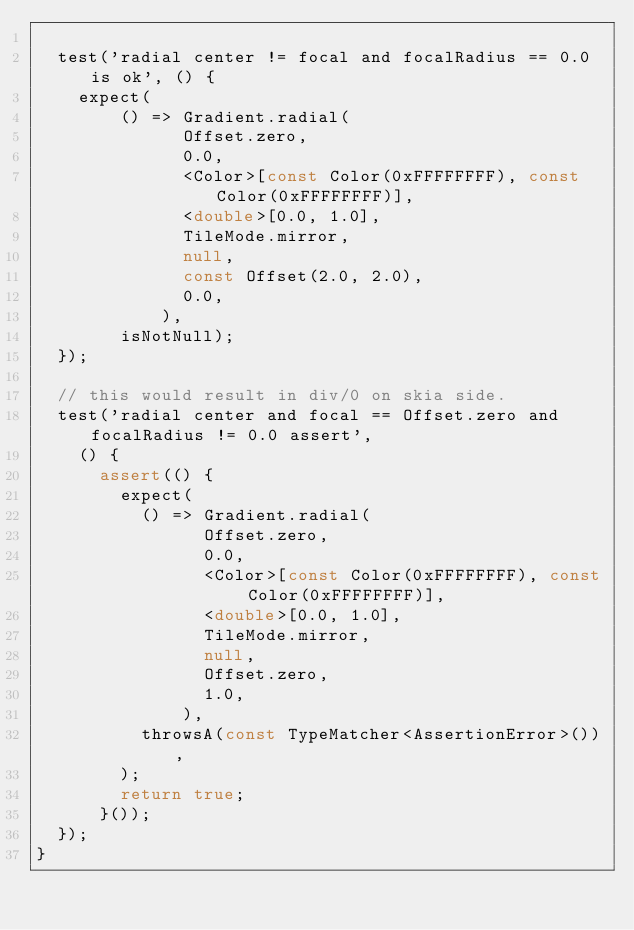<code> <loc_0><loc_0><loc_500><loc_500><_Dart_>
  test('radial center != focal and focalRadius == 0.0 is ok', () {
    expect(
        () => Gradient.radial(
              Offset.zero,
              0.0,
              <Color>[const Color(0xFFFFFFFF), const Color(0xFFFFFFFF)],
              <double>[0.0, 1.0],
              TileMode.mirror,
              null,
              const Offset(2.0, 2.0),
              0.0,
            ),
        isNotNull);
  });

  // this would result in div/0 on skia side.
  test('radial center and focal == Offset.zero and focalRadius != 0.0 assert',
    () {
      assert(() {
        expect(
          () => Gradient.radial(
                Offset.zero,
                0.0,
                <Color>[const Color(0xFFFFFFFF), const Color(0xFFFFFFFF)],
                <double>[0.0, 1.0],
                TileMode.mirror,
                null,
                Offset.zero,
                1.0,
              ),
          throwsA(const TypeMatcher<AssertionError>()),
        );
        return true;
      }());
  });
}
</code> 